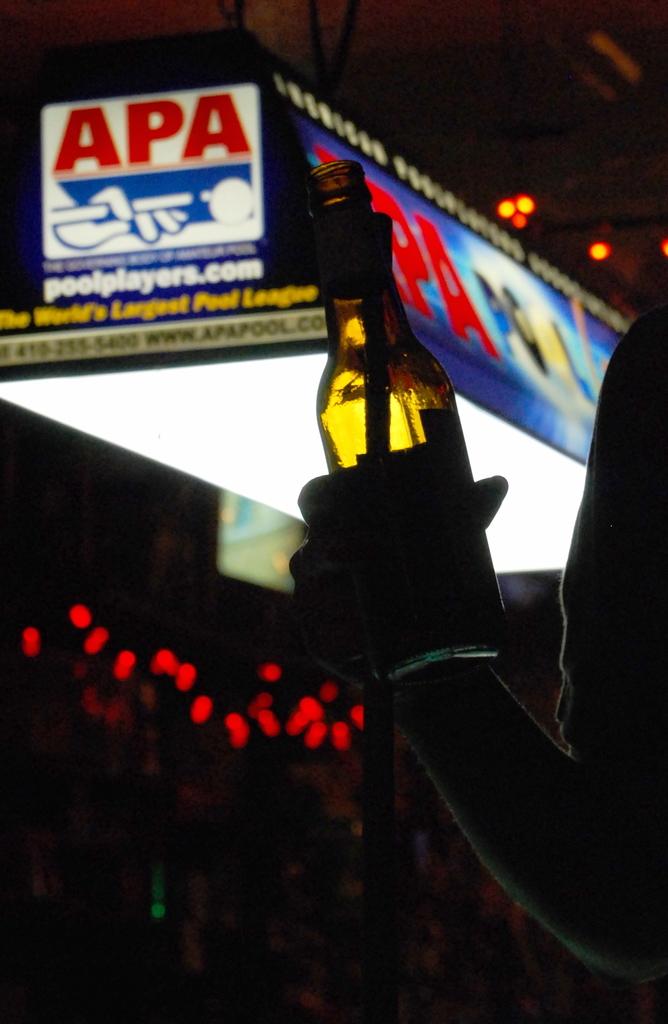What is the website for this pool league?
Offer a very short reply. Poolplayers.com. What is the pool league called?
Offer a very short reply. Apa. 